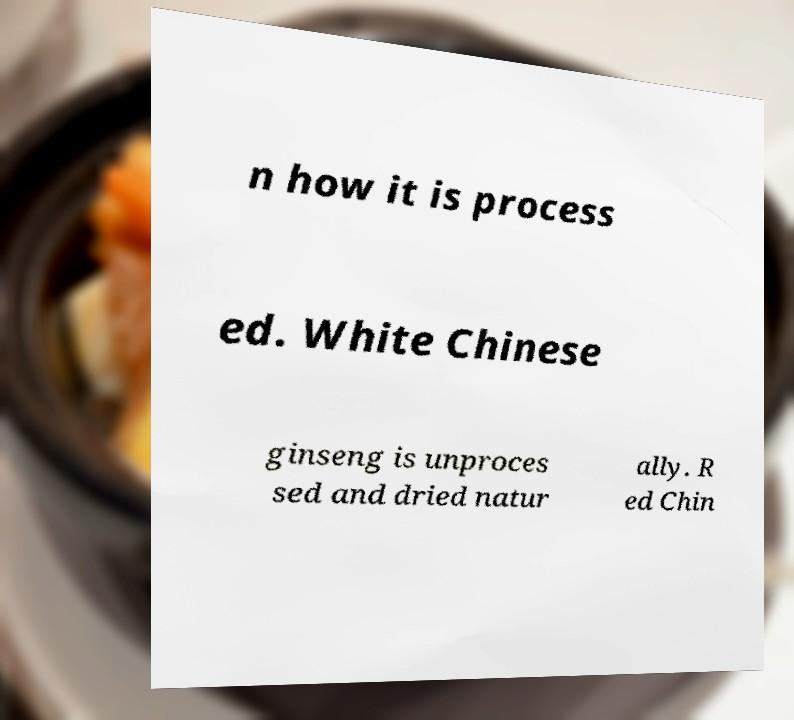I need the written content from this picture converted into text. Can you do that? n how it is process ed. White Chinese ginseng is unproces sed and dried natur ally. R ed Chin 